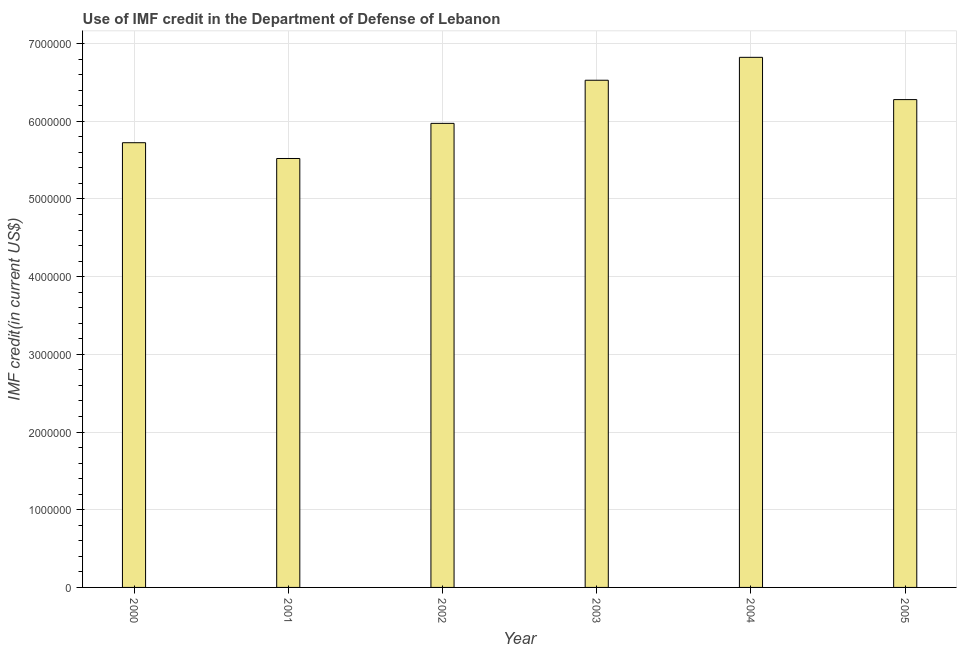Does the graph contain grids?
Provide a succinct answer. Yes. What is the title of the graph?
Give a very brief answer. Use of IMF credit in the Department of Defense of Lebanon. What is the label or title of the Y-axis?
Provide a short and direct response. IMF credit(in current US$). What is the use of imf credit in dod in 2003?
Provide a succinct answer. 6.53e+06. Across all years, what is the maximum use of imf credit in dod?
Your answer should be very brief. 6.82e+06. Across all years, what is the minimum use of imf credit in dod?
Offer a terse response. 5.52e+06. In which year was the use of imf credit in dod maximum?
Your answer should be very brief. 2004. In which year was the use of imf credit in dod minimum?
Your response must be concise. 2001. What is the sum of the use of imf credit in dod?
Keep it short and to the point. 3.68e+07. What is the difference between the use of imf credit in dod in 2000 and 2001?
Make the answer very short. 2.03e+05. What is the average use of imf credit in dod per year?
Your response must be concise. 6.14e+06. What is the median use of imf credit in dod?
Provide a short and direct response. 6.13e+06. What is the ratio of the use of imf credit in dod in 2000 to that in 2002?
Your answer should be very brief. 0.96. Is the use of imf credit in dod in 2000 less than that in 2005?
Provide a short and direct response. Yes. Is the difference between the use of imf credit in dod in 2000 and 2005 greater than the difference between any two years?
Give a very brief answer. No. What is the difference between the highest and the second highest use of imf credit in dod?
Make the answer very short. 2.95e+05. What is the difference between the highest and the lowest use of imf credit in dod?
Give a very brief answer. 1.30e+06. In how many years, is the use of imf credit in dod greater than the average use of imf credit in dod taken over all years?
Your response must be concise. 3. How many bars are there?
Your answer should be very brief. 6. Are all the bars in the graph horizontal?
Offer a very short reply. No. What is the difference between two consecutive major ticks on the Y-axis?
Offer a very short reply. 1.00e+06. What is the IMF credit(in current US$) in 2000?
Offer a terse response. 5.72e+06. What is the IMF credit(in current US$) of 2001?
Keep it short and to the point. 5.52e+06. What is the IMF credit(in current US$) in 2002?
Provide a short and direct response. 5.97e+06. What is the IMF credit(in current US$) in 2003?
Your response must be concise. 6.53e+06. What is the IMF credit(in current US$) of 2004?
Your response must be concise. 6.82e+06. What is the IMF credit(in current US$) of 2005?
Give a very brief answer. 6.28e+06. What is the difference between the IMF credit(in current US$) in 2000 and 2001?
Ensure brevity in your answer.  2.03e+05. What is the difference between the IMF credit(in current US$) in 2000 and 2002?
Ensure brevity in your answer.  -2.49e+05. What is the difference between the IMF credit(in current US$) in 2000 and 2003?
Your answer should be very brief. -8.04e+05. What is the difference between the IMF credit(in current US$) in 2000 and 2004?
Your answer should be very brief. -1.10e+06. What is the difference between the IMF credit(in current US$) in 2000 and 2005?
Your answer should be compact. -5.55e+05. What is the difference between the IMF credit(in current US$) in 2001 and 2002?
Offer a very short reply. -4.52e+05. What is the difference between the IMF credit(in current US$) in 2001 and 2003?
Make the answer very short. -1.01e+06. What is the difference between the IMF credit(in current US$) in 2001 and 2004?
Provide a short and direct response. -1.30e+06. What is the difference between the IMF credit(in current US$) in 2001 and 2005?
Provide a short and direct response. -7.58e+05. What is the difference between the IMF credit(in current US$) in 2002 and 2003?
Your response must be concise. -5.55e+05. What is the difference between the IMF credit(in current US$) in 2002 and 2004?
Give a very brief answer. -8.50e+05. What is the difference between the IMF credit(in current US$) in 2002 and 2005?
Offer a very short reply. -3.06e+05. What is the difference between the IMF credit(in current US$) in 2003 and 2004?
Your answer should be compact. -2.95e+05. What is the difference between the IMF credit(in current US$) in 2003 and 2005?
Give a very brief answer. 2.49e+05. What is the difference between the IMF credit(in current US$) in 2004 and 2005?
Provide a short and direct response. 5.44e+05. What is the ratio of the IMF credit(in current US$) in 2000 to that in 2002?
Keep it short and to the point. 0.96. What is the ratio of the IMF credit(in current US$) in 2000 to that in 2003?
Keep it short and to the point. 0.88. What is the ratio of the IMF credit(in current US$) in 2000 to that in 2004?
Give a very brief answer. 0.84. What is the ratio of the IMF credit(in current US$) in 2000 to that in 2005?
Give a very brief answer. 0.91. What is the ratio of the IMF credit(in current US$) in 2001 to that in 2002?
Ensure brevity in your answer.  0.92. What is the ratio of the IMF credit(in current US$) in 2001 to that in 2003?
Provide a succinct answer. 0.85. What is the ratio of the IMF credit(in current US$) in 2001 to that in 2004?
Provide a short and direct response. 0.81. What is the ratio of the IMF credit(in current US$) in 2001 to that in 2005?
Your response must be concise. 0.88. What is the ratio of the IMF credit(in current US$) in 2002 to that in 2003?
Offer a very short reply. 0.92. What is the ratio of the IMF credit(in current US$) in 2002 to that in 2005?
Give a very brief answer. 0.95. What is the ratio of the IMF credit(in current US$) in 2003 to that in 2004?
Provide a short and direct response. 0.96. What is the ratio of the IMF credit(in current US$) in 2004 to that in 2005?
Your answer should be very brief. 1.09. 